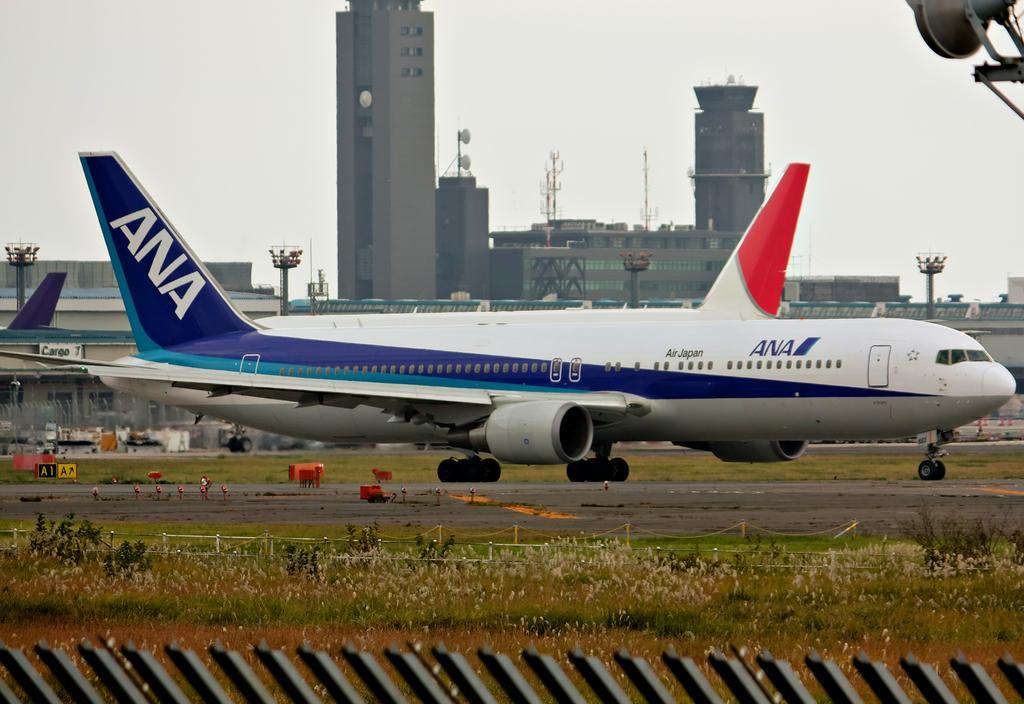Could you give a brief overview of what you see in this image? In this pictures I can see few aeroplanes on the runway and I can see few buildings and pole lights and few towers and few plants and buildings and a cloudy sky. 